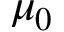Convert formula to latex. <formula><loc_0><loc_0><loc_500><loc_500>\mu _ { 0 }</formula> 